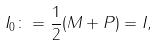<formula> <loc_0><loc_0><loc_500><loc_500>I _ { 0 } \colon = \frac { 1 } { 2 } ( M + P ) = I ,</formula> 